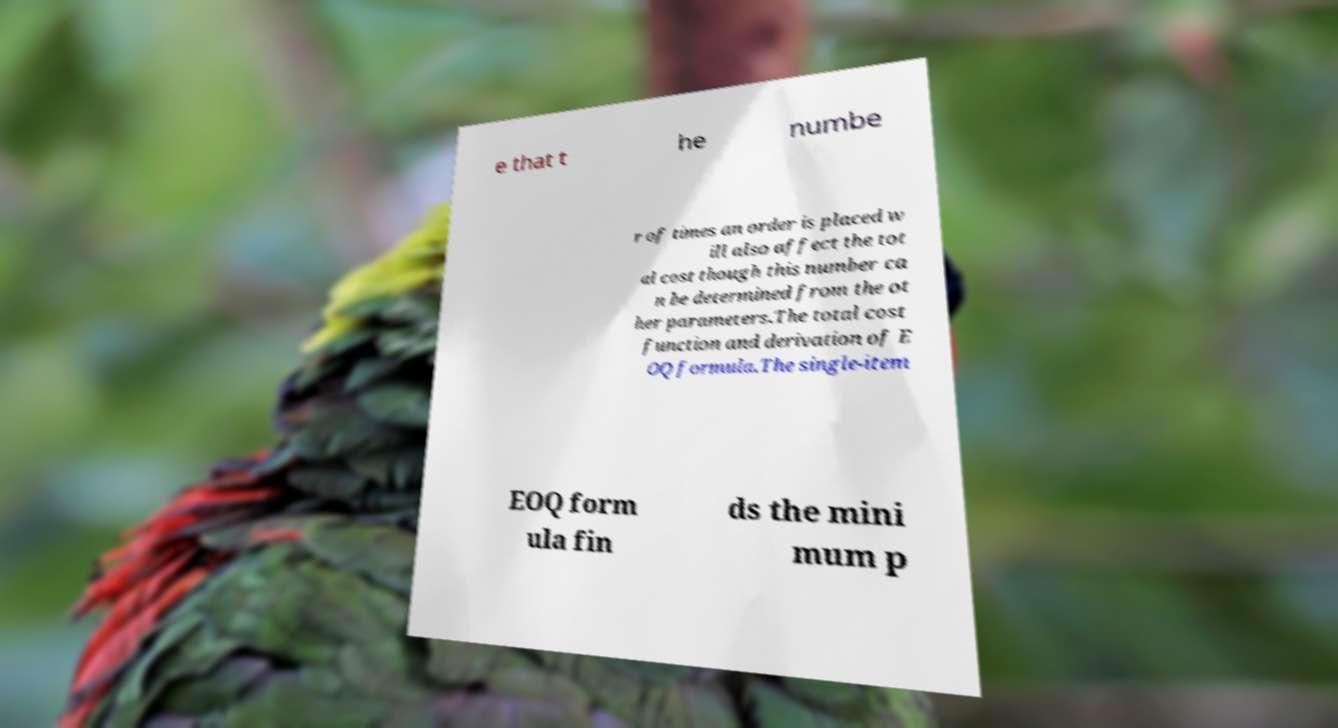For documentation purposes, I need the text within this image transcribed. Could you provide that? e that t he numbe r of times an order is placed w ill also affect the tot al cost though this number ca n be determined from the ot her parameters.The total cost function and derivation of E OQ formula.The single-item EOQ form ula fin ds the mini mum p 